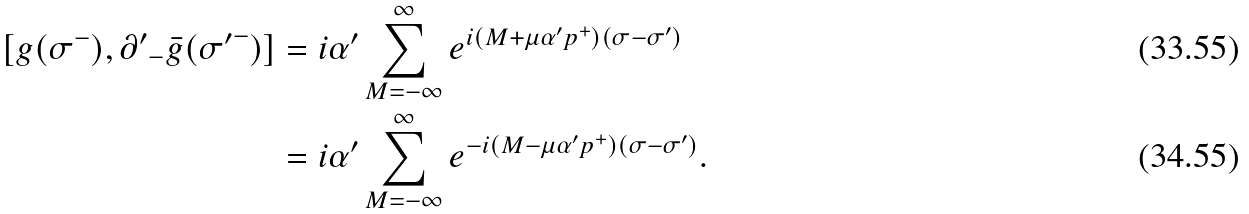<formula> <loc_0><loc_0><loc_500><loc_500>[ g ( \sigma ^ { - } ) , { \partial ^ { \prime } } _ { - } \bar { g } ( { \sigma ^ { \prime } } ^ { - } ) ] & = i \alpha ^ { \prime } \sum _ { M = - \infty } ^ { \infty } e ^ { i ( M + \mu \alpha ^ { \prime } p ^ { + } ) ( \sigma - \sigma ^ { \prime } ) } \\ & = i \alpha ^ { \prime } \sum _ { M = - \infty } ^ { \infty } e ^ { - i ( M - \mu \alpha ^ { \prime } p ^ { + } ) ( \sigma - \sigma ^ { \prime } ) } .</formula> 